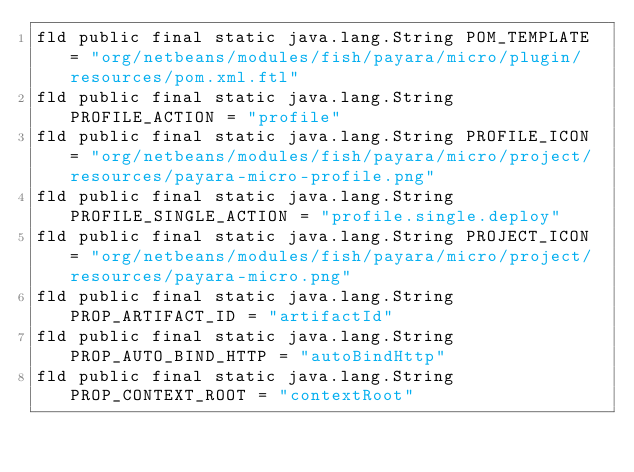<code> <loc_0><loc_0><loc_500><loc_500><_SML_>fld public final static java.lang.String POM_TEMPLATE = "org/netbeans/modules/fish/payara/micro/plugin/resources/pom.xml.ftl"
fld public final static java.lang.String PROFILE_ACTION = "profile"
fld public final static java.lang.String PROFILE_ICON = "org/netbeans/modules/fish/payara/micro/project/resources/payara-micro-profile.png"
fld public final static java.lang.String PROFILE_SINGLE_ACTION = "profile.single.deploy"
fld public final static java.lang.String PROJECT_ICON = "org/netbeans/modules/fish/payara/micro/project/resources/payara-micro.png"
fld public final static java.lang.String PROP_ARTIFACT_ID = "artifactId"
fld public final static java.lang.String PROP_AUTO_BIND_HTTP = "autoBindHttp"
fld public final static java.lang.String PROP_CONTEXT_ROOT = "contextRoot"</code> 